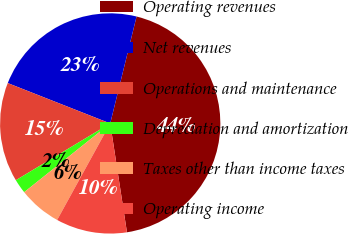<chart> <loc_0><loc_0><loc_500><loc_500><pie_chart><fcel>Operating revenues<fcel>Net revenues<fcel>Operations and maintenance<fcel>Depreciation and amortization<fcel>Taxes other than income taxes<fcel>Operating income<nl><fcel>43.72%<fcel>22.87%<fcel>14.59%<fcel>2.11%<fcel>6.27%<fcel>10.43%<nl></chart> 